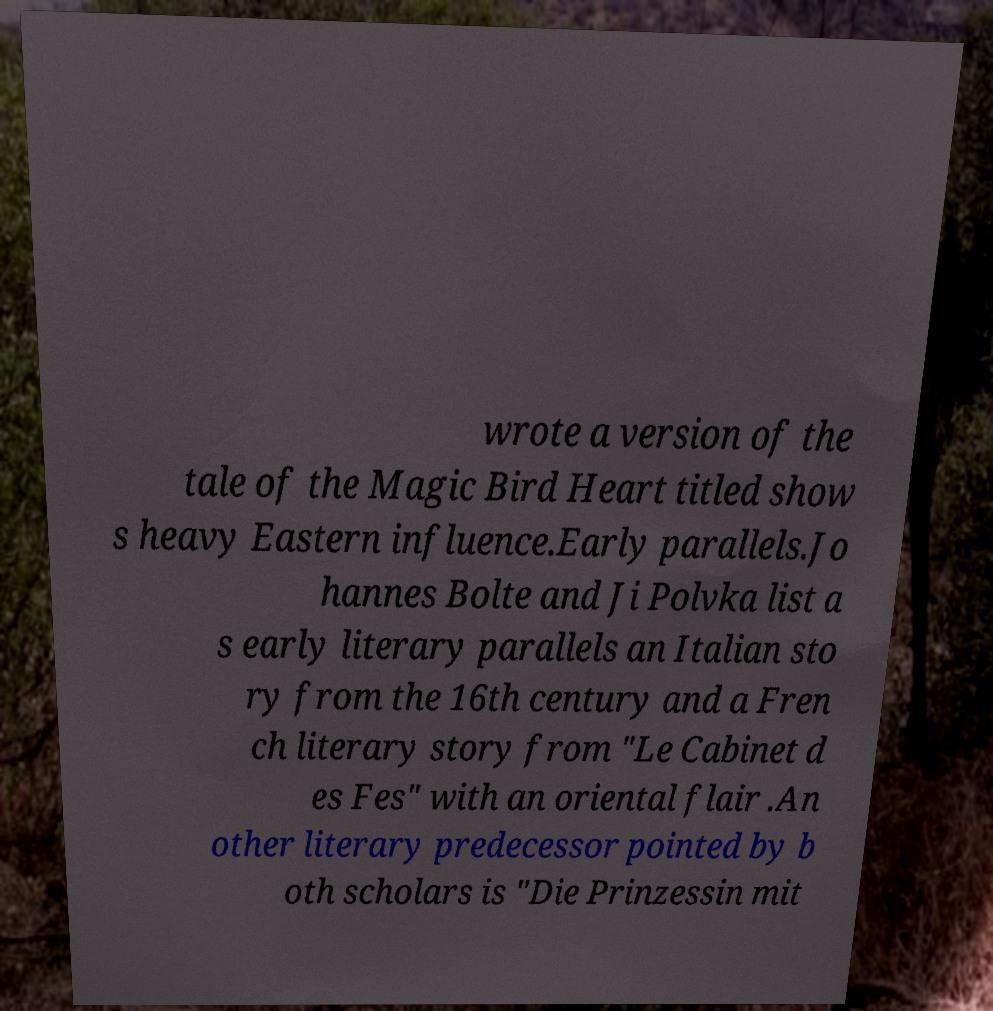Could you extract and type out the text from this image? wrote a version of the tale of the Magic Bird Heart titled show s heavy Eastern influence.Early parallels.Jo hannes Bolte and Ji Polvka list a s early literary parallels an Italian sto ry from the 16th century and a Fren ch literary story from "Le Cabinet d es Fes" with an oriental flair .An other literary predecessor pointed by b oth scholars is "Die Prinzessin mit 